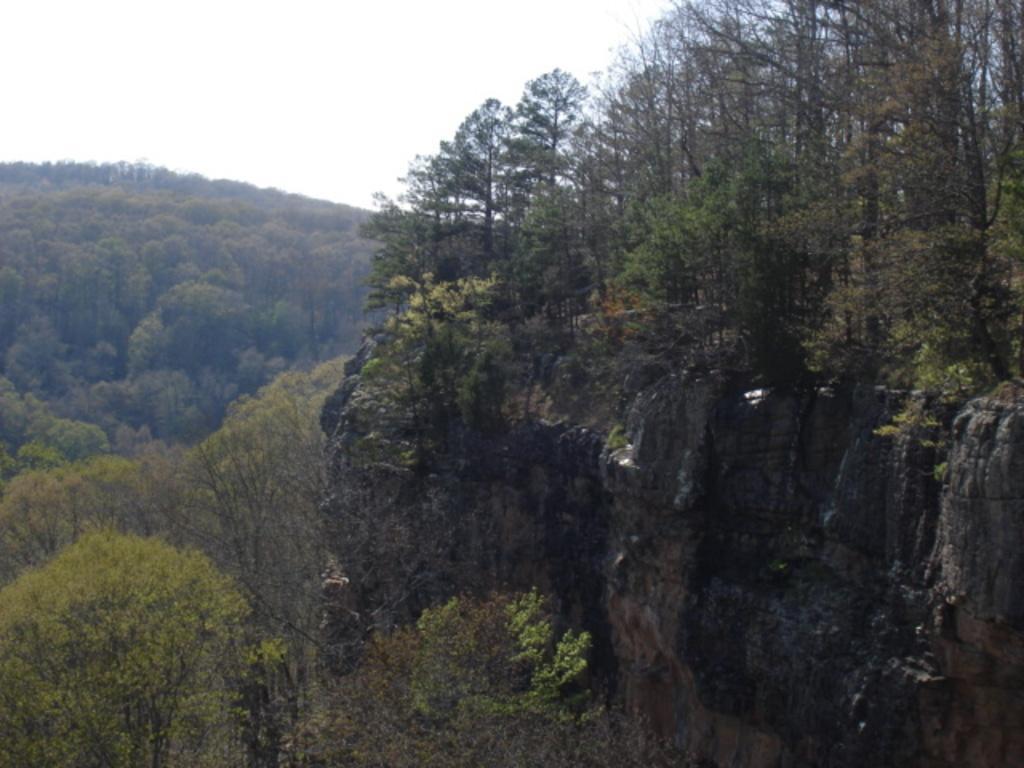In one or two sentences, can you explain what this image depicts? This is an outside view. On the right side there is a rock. In the background, I can see many trees. At the top, I can see the sky. 